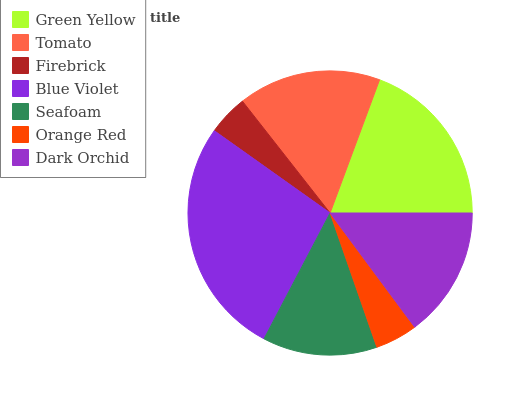Is Firebrick the minimum?
Answer yes or no. Yes. Is Blue Violet the maximum?
Answer yes or no. Yes. Is Tomato the minimum?
Answer yes or no. No. Is Tomato the maximum?
Answer yes or no. No. Is Green Yellow greater than Tomato?
Answer yes or no. Yes. Is Tomato less than Green Yellow?
Answer yes or no. Yes. Is Tomato greater than Green Yellow?
Answer yes or no. No. Is Green Yellow less than Tomato?
Answer yes or no. No. Is Dark Orchid the high median?
Answer yes or no. Yes. Is Dark Orchid the low median?
Answer yes or no. Yes. Is Orange Red the high median?
Answer yes or no. No. Is Seafoam the low median?
Answer yes or no. No. 